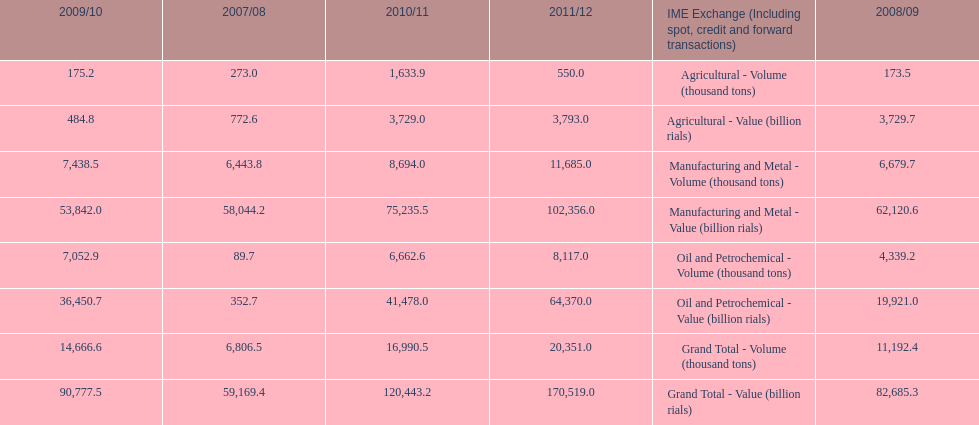Did 2010/11 or 2011/12 make more in grand total value? 2011/12. 